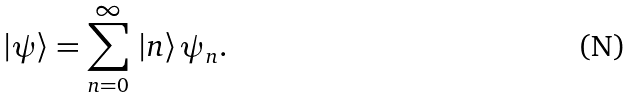Convert formula to latex. <formula><loc_0><loc_0><loc_500><loc_500>| \psi \rangle = \sum _ { n = 0 } ^ { \infty } \, | n \rangle \, \psi _ { n } .</formula> 